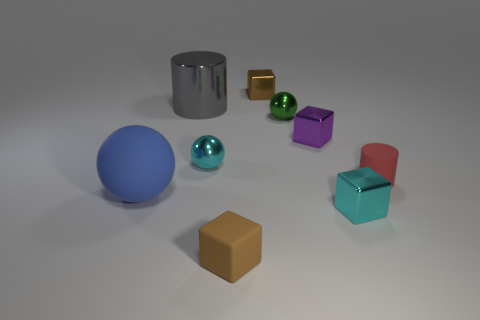Is there anything else that is made of the same material as the gray cylinder?
Your answer should be compact. Yes. How many large objects are either purple blocks or cyan cubes?
Your answer should be very brief. 0. What number of objects are either small cubes that are behind the purple metallic object or large gray metallic cylinders?
Provide a succinct answer. 2. Do the big rubber ball and the tiny rubber cylinder have the same color?
Make the answer very short. No. What number of other objects are the same shape as the large gray thing?
Make the answer very short. 1. How many purple things are rubber spheres or metal cylinders?
Keep it short and to the point. 0. What is the color of the tiny cube that is made of the same material as the small cylinder?
Make the answer very short. Brown. Is the tiny brown cube that is in front of the gray metal object made of the same material as the tiny object that is behind the large metallic object?
Keep it short and to the point. No. What is the size of the metal thing that is the same color as the matte cube?
Provide a succinct answer. Small. What is the tiny brown thing in front of the red matte thing made of?
Offer a terse response. Rubber. 